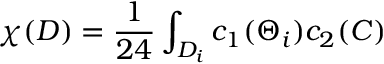Convert formula to latex. <formula><loc_0><loc_0><loc_500><loc_500>\chi ( D ) = \frac { 1 } { 2 4 } \int _ { D _ { i } } c _ { 1 } ( \Theta _ { i } ) c _ { 2 } ( C )</formula> 